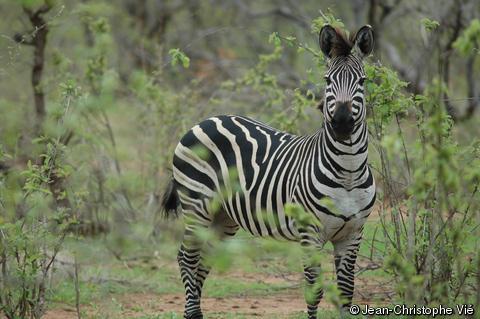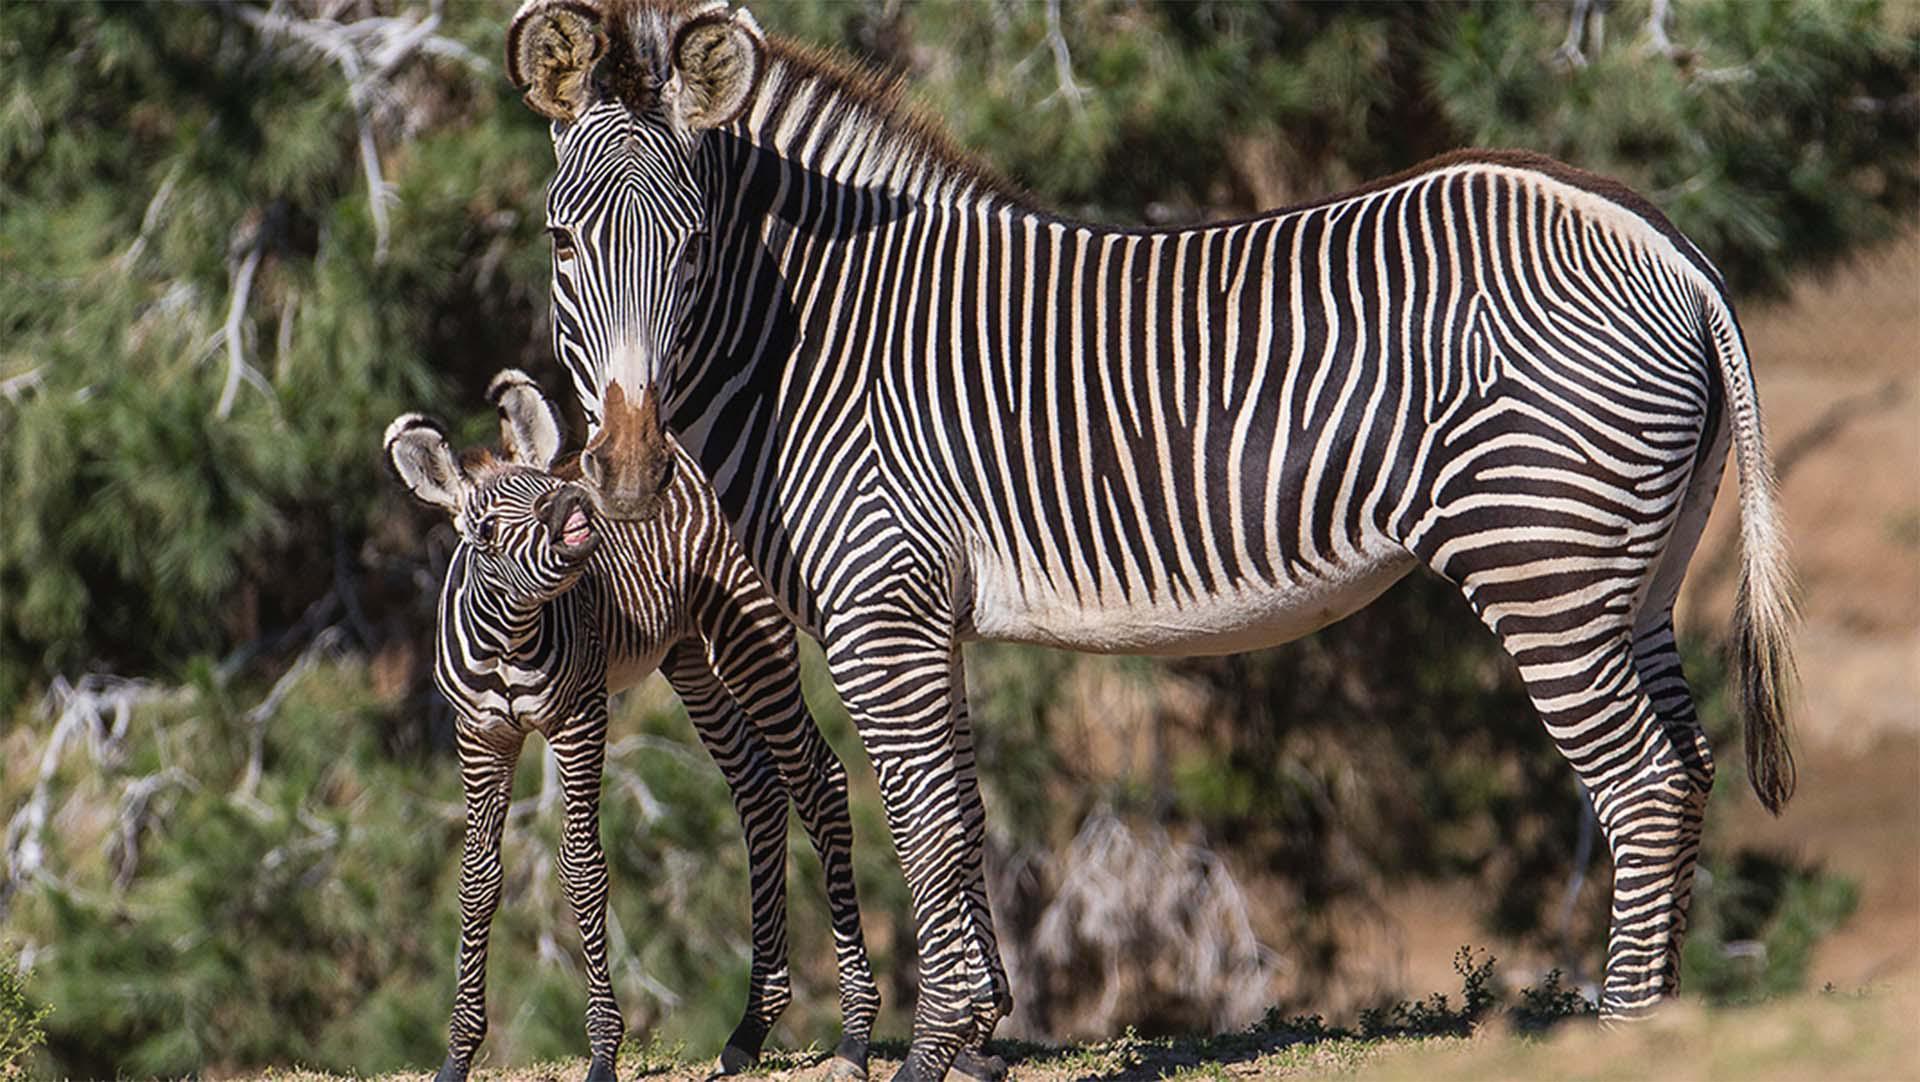The first image is the image on the left, the second image is the image on the right. Given the left and right images, does the statement "There are two zebras, one adult and one child facing right." hold true? Answer yes or no. No. The first image is the image on the left, the second image is the image on the right. Analyze the images presented: Is the assertion "There are three zebras and one of them is a juvenile." valid? Answer yes or no. Yes. 